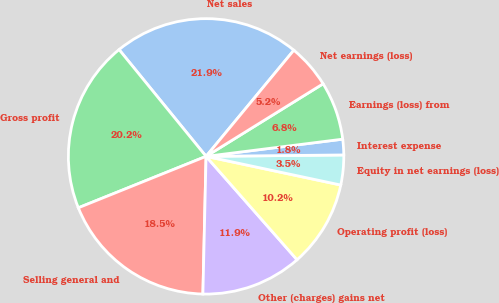Convert chart. <chart><loc_0><loc_0><loc_500><loc_500><pie_chart><fcel>Net sales<fcel>Gross profit<fcel>Selling general and<fcel>Other (charges) gains net<fcel>Operating profit (loss)<fcel>Equity in net earnings (loss)<fcel>Interest expense<fcel>Earnings (loss) from<fcel>Net earnings (loss)<nl><fcel>21.88%<fcel>20.21%<fcel>18.54%<fcel>11.85%<fcel>10.18%<fcel>3.5%<fcel>1.83%<fcel>6.84%<fcel>5.17%<nl></chart> 